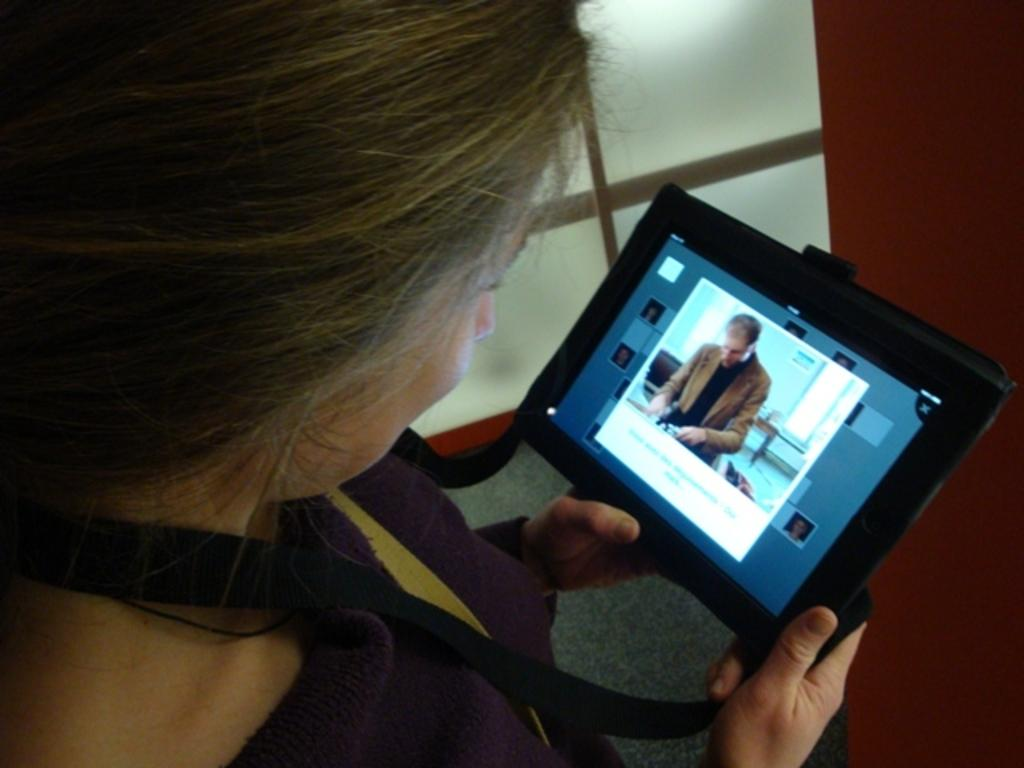Who is present in the image? There is a woman in the image. What is the woman doing in the image? The woman is standing and holding a note tab. What is the woman's facial expression in the image? The woman is smiling in the image. What is the woman looking at in the image? The woman is looking at a screen in the image. What can be seen behind the woman in the image? There is a wall in front of the woman and a glass window beside her in the image. How many fingers does the woman have on her left hand in the image? The image does not provide enough detail to determine the number of fingers on the woman's left hand. 